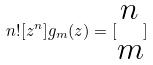<formula> <loc_0><loc_0><loc_500><loc_500>n ! [ z ^ { n } ] g _ { m } ( z ) = [ \begin{matrix} n \\ m \end{matrix} ]</formula> 